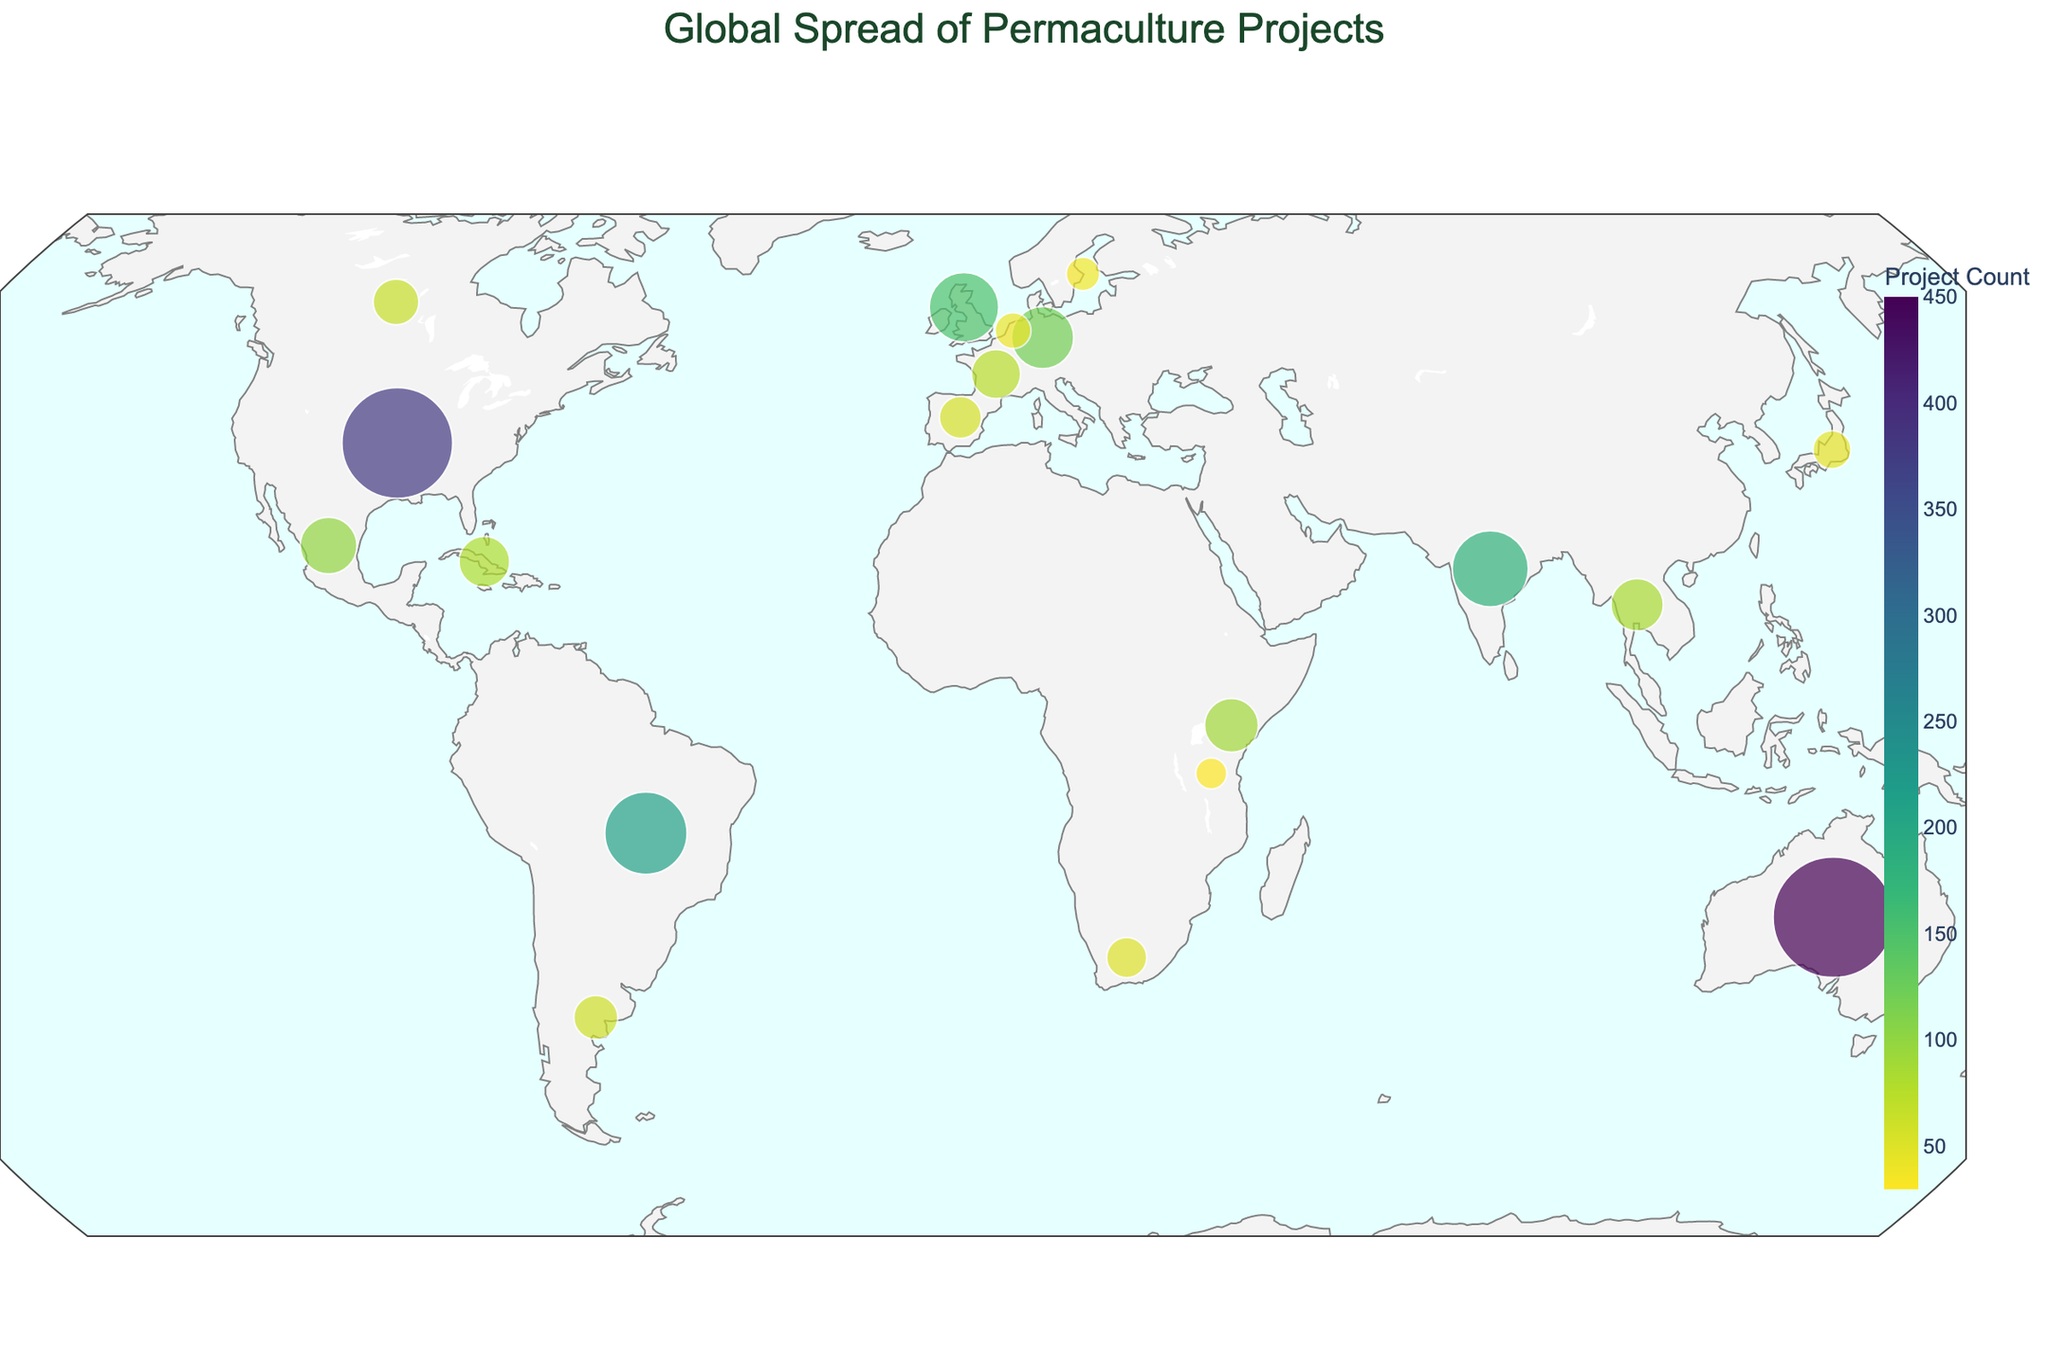Which country has the highest number of permaculture projects? According to the plot, Australia has the largest circle, indicating it has the highest ProjectCount.
Answer: Australia Which country is predominantly associated with Urban Permaculture? The dominant type for Urban Permaculture is highlighted when hovering over the United States in the plot.
Answer: United States How does the number of permaculture projects in Brazil compare to India? By examining the size of the circles, Brazil has a larger circle than India, which means Brazil has more projects (210) compared to India (180).
Answer: Brazil has more projects than India What is the dominant permutation type in Kenya? Hovering over Kenya on the plot reveals the dominant type, which is "Dryland Permaculture."
Answer: Dryland Permaculture Are there more permaculture projects in the United Kingdom or Germany? By comparing the circle sizes related to the United Kingdom and Germany, the UK (150 projects) has more projects than Germany (120 projects).
Answer: United Kingdom Which country focuses on Rice-based Systems? The plot indicates that Thailand is associated with the dominant type "Rice-based Systems."
Answer: Thailand What is the total number of permaculture projects in Argentina, Spain, and Canada combined? Summing up the ProjectCounts for Argentina (60), Spain (55), and Canada (65) gives a total of 180.
Answer: 180 Which countries have less than 50 permaculture projects? Visual inspection of the plot shows that Japan, Netherlands, Sweden, and Tanzania have circles representing less than 50 projects each.
Answer: Japan, Netherlands, Sweden, Tanzania Which country is associated with Regenerative Grazing? Hovering over New Zealand on the plot indicates that it is associated with the dominant type "Regenerative Grazing."
Answer: New Zealand How does the density of projects in Africa compare to South America? Africa has circles representing Kenya (90) and Tanzania (30), totaling 120 projects, while South America has Brazil (210) and Argentina (60), totaling 270 projects. Therefore, South America has more permaculture projects.
Answer: South America has more projects 